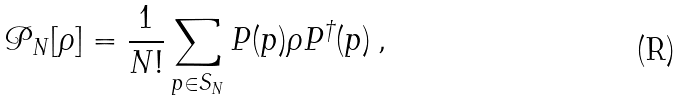Convert formula to latex. <formula><loc_0><loc_0><loc_500><loc_500>\mathcal { P } _ { N } [ \rho ] = \frac { 1 } { N ! } \sum _ { p \in S _ { N } } P ( p ) \rho P ^ { \dag } ( p ) \, ,</formula> 